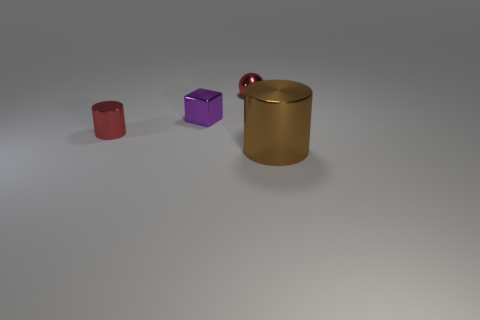Add 1 small cylinders. How many objects exist? 5 Subtract all balls. How many objects are left? 3 Subtract 0 gray spheres. How many objects are left? 4 Subtract all green rubber spheres. Subtract all purple blocks. How many objects are left? 3 Add 2 large brown objects. How many large brown objects are left? 3 Add 2 big purple matte cylinders. How many big purple matte cylinders exist? 2 